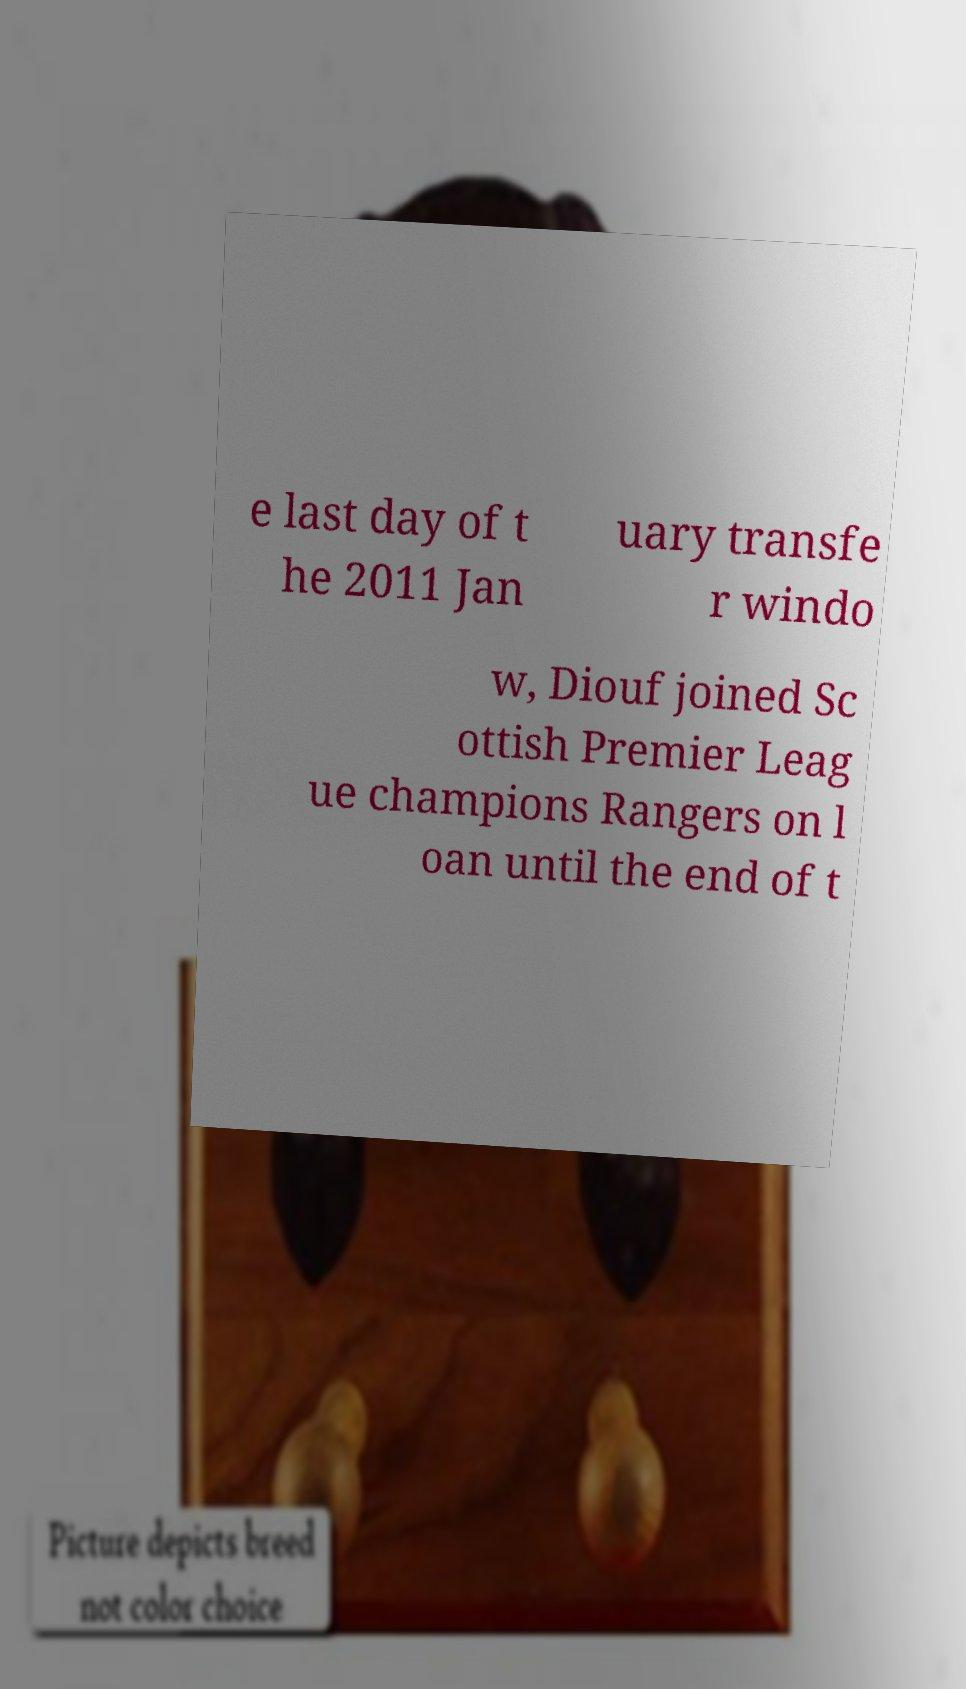Please identify and transcribe the text found in this image. e last day of t he 2011 Jan uary transfe r windo w, Diouf joined Sc ottish Premier Leag ue champions Rangers on l oan until the end of t 